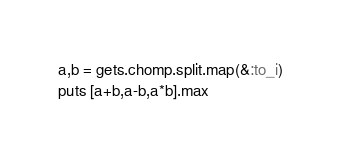Convert code to text. <code><loc_0><loc_0><loc_500><loc_500><_Ruby_>a,b = gets.chomp.split.map(&:to_i)
puts [a+b,a-b,a*b].max</code> 